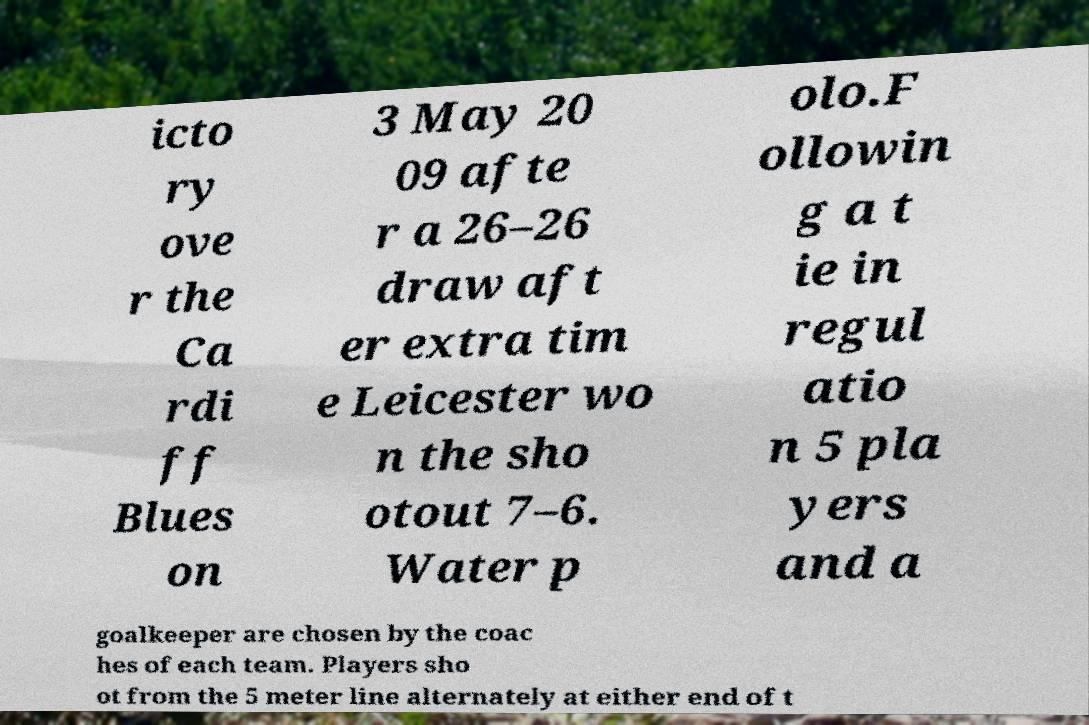There's text embedded in this image that I need extracted. Can you transcribe it verbatim? icto ry ove r the Ca rdi ff Blues on 3 May 20 09 afte r a 26–26 draw aft er extra tim e Leicester wo n the sho otout 7–6. Water p olo.F ollowin g a t ie in regul atio n 5 pla yers and a goalkeeper are chosen by the coac hes of each team. Players sho ot from the 5 meter line alternately at either end of t 